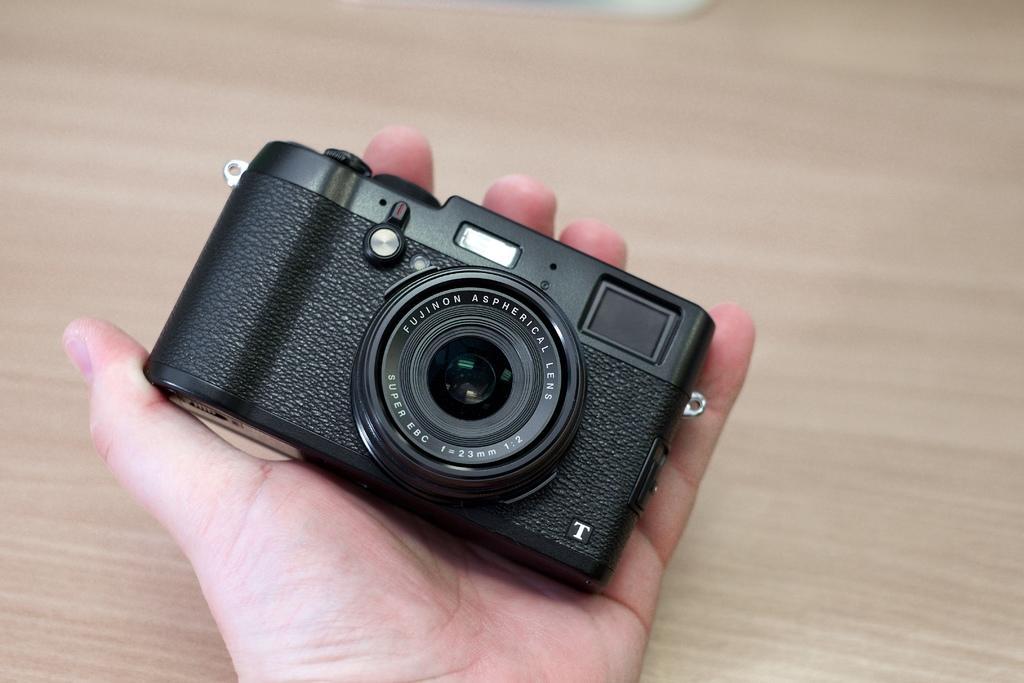How would you summarize this image in a sentence or two? In the image,there is a hand and it is holding a camera. 